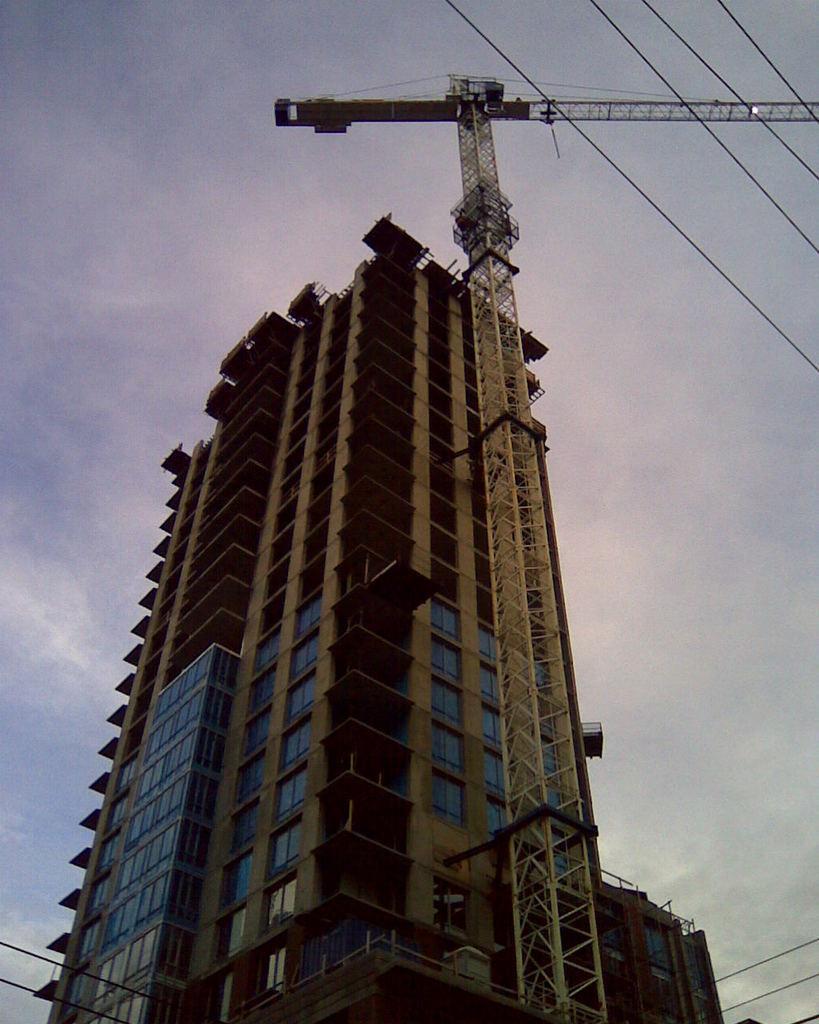Describe this image in one or two sentences. In the image we can see there is a building and there is a construction crane. There is a cloudy sky. 